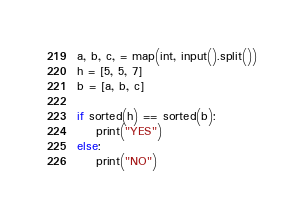Convert code to text. <code><loc_0><loc_0><loc_500><loc_500><_Python_>a, b, c, = map(int, input().split())
h = [5, 5, 7]
b = [a, b, c]

if sorted(h) == sorted(b):
    print("YES")
else:
    print("NO")
</code> 